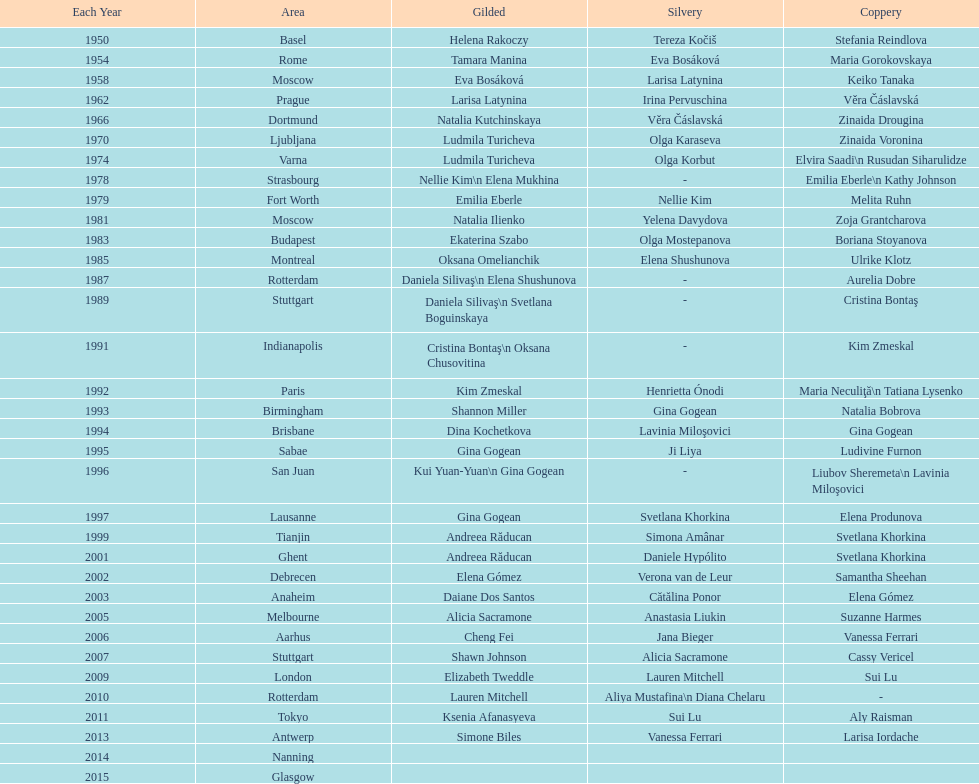Until 2013, what is the cumulative sum of floor exercise gold medals achieved by american women during the world championships? 5. 